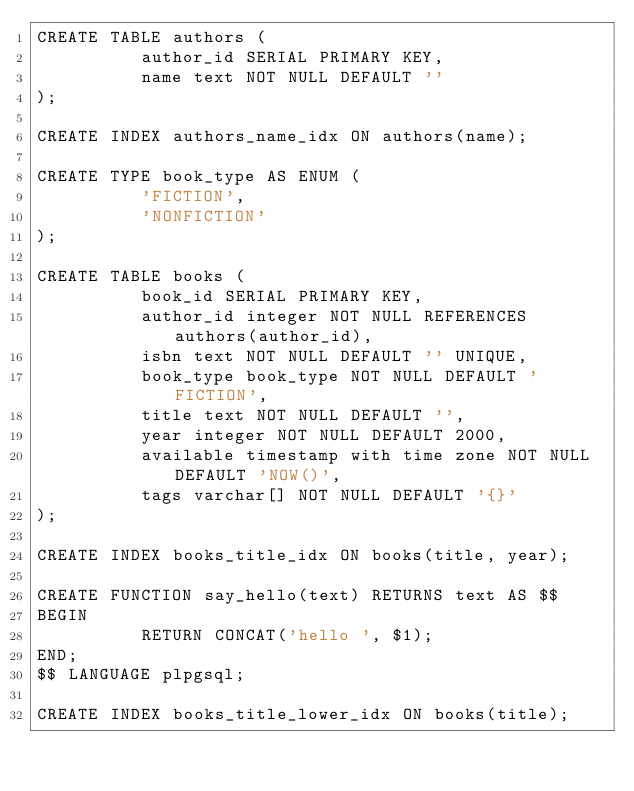<code> <loc_0><loc_0><loc_500><loc_500><_SQL_>CREATE TABLE authors (
          author_id SERIAL PRIMARY KEY,
          name text NOT NULL DEFAULT ''
);

CREATE INDEX authors_name_idx ON authors(name);

CREATE TYPE book_type AS ENUM (
          'FICTION',
          'NONFICTION'
);

CREATE TABLE books (
          book_id SERIAL PRIMARY KEY,
          author_id integer NOT NULL REFERENCES authors(author_id),
          isbn text NOT NULL DEFAULT '' UNIQUE,
          book_type book_type NOT NULL DEFAULT 'FICTION',
          title text NOT NULL DEFAULT '',
          year integer NOT NULL DEFAULT 2000,
          available timestamp with time zone NOT NULL DEFAULT 'NOW()',
          tags varchar[] NOT NULL DEFAULT '{}'
);

CREATE INDEX books_title_idx ON books(title, year);

CREATE FUNCTION say_hello(text) RETURNS text AS $$
BEGIN
          RETURN CONCAT('hello ', $1);
END;
$$ LANGUAGE plpgsql;

CREATE INDEX books_title_lower_idx ON books(title);
</code> 